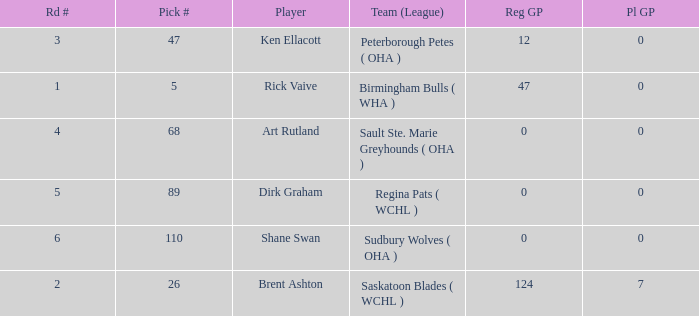How many reg GP for rick vaive in round 1? None. 